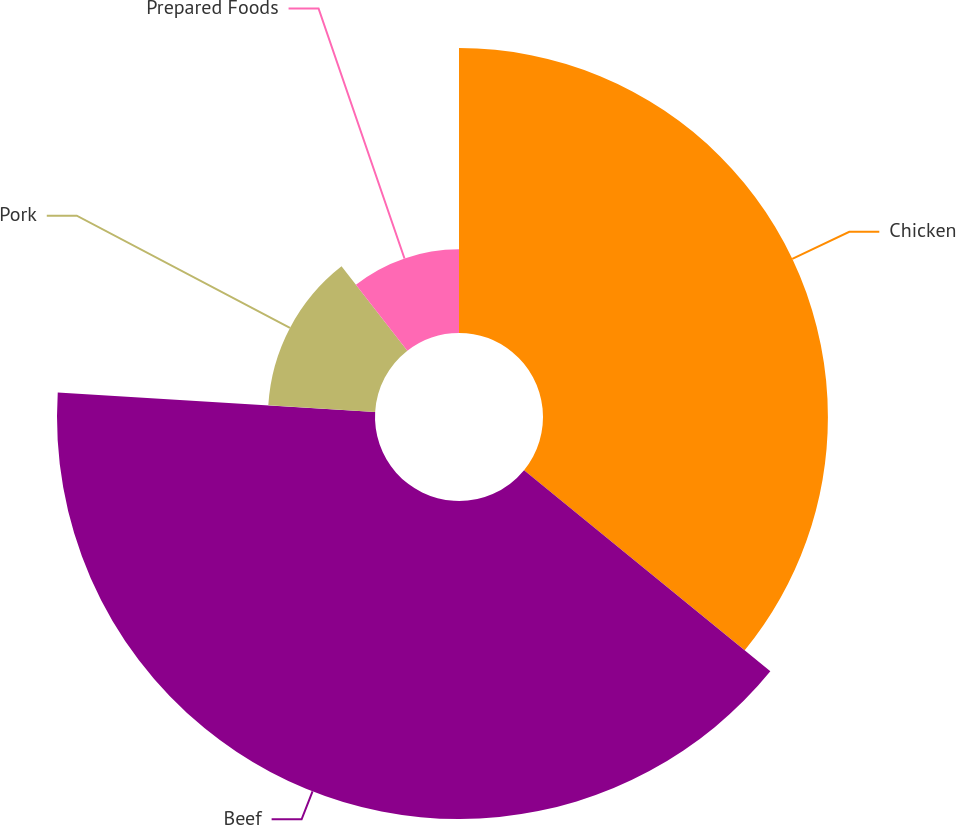Convert chart. <chart><loc_0><loc_0><loc_500><loc_500><pie_chart><fcel>Chicken<fcel>Beef<fcel>Pork<fcel>Prepared Foods<nl><fcel>35.9%<fcel>40.07%<fcel>13.49%<fcel>10.54%<nl></chart> 